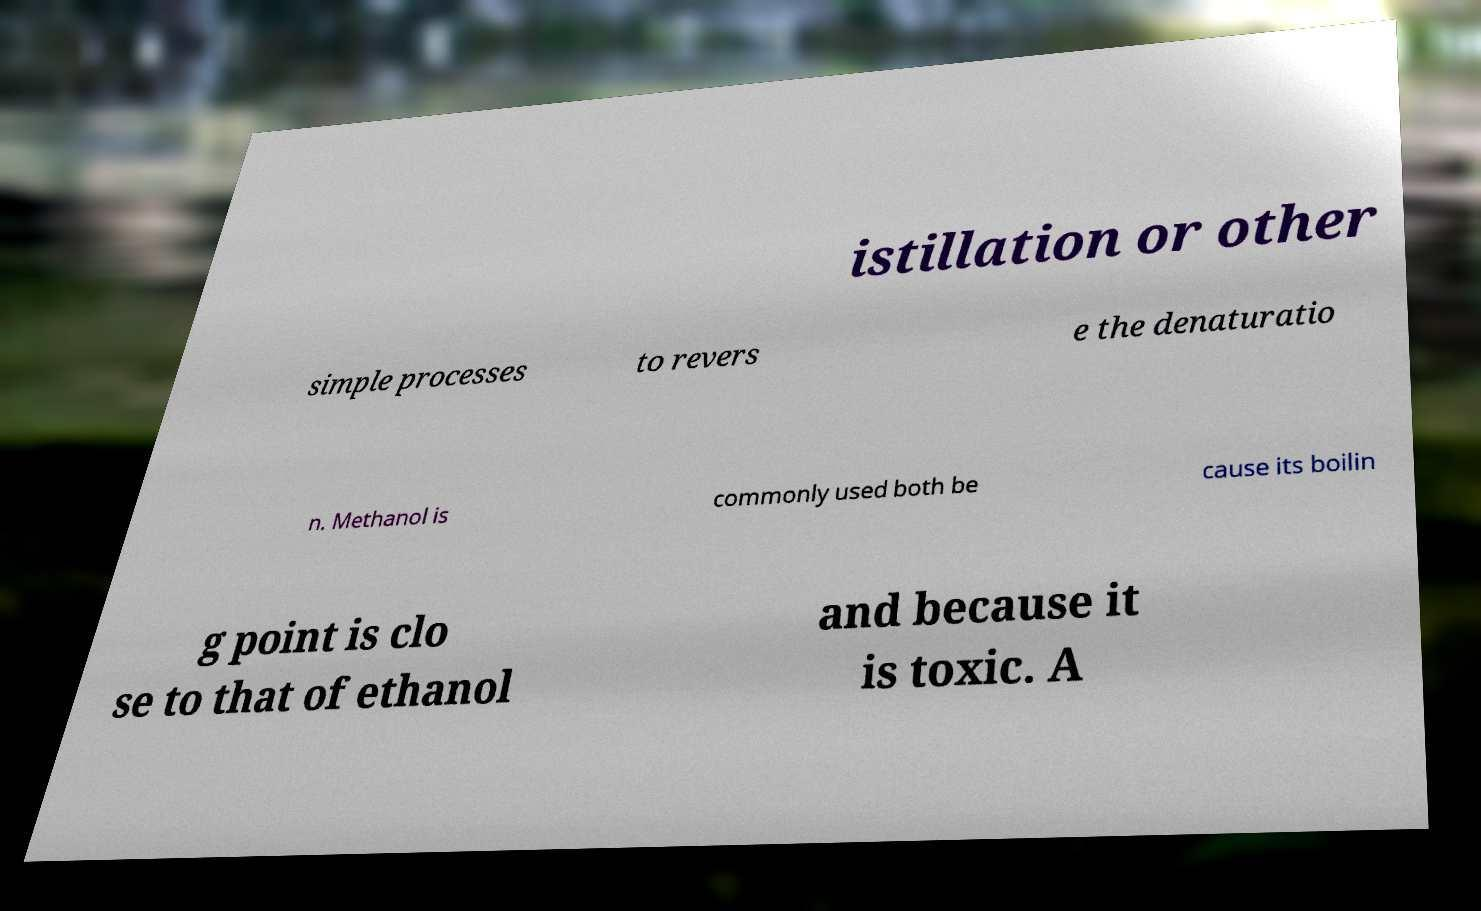Could you extract and type out the text from this image? istillation or other simple processes to revers e the denaturatio n. Methanol is commonly used both be cause its boilin g point is clo se to that of ethanol and because it is toxic. A 